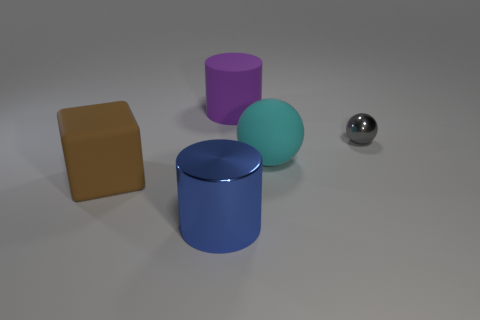What material is the big blue cylinder?
Your response must be concise. Metal. What is the material of the cyan thing that is the same size as the purple matte cylinder?
Provide a succinct answer. Rubber. Are there any brown rubber blocks that have the same size as the purple matte cylinder?
Give a very brief answer. Yes. Are there an equal number of shiny things behind the cyan matte sphere and blue cylinders that are behind the small sphere?
Provide a short and direct response. No. Is the number of brown rubber things greater than the number of objects?
Your answer should be very brief. No. How many shiny things are blue things or yellow spheres?
Offer a very short reply. 1. There is a cylinder in front of the metal thing behind the big rubber thing right of the purple object; what is it made of?
Offer a very short reply. Metal. What color is the thing behind the metal thing right of the big cyan object?
Your answer should be compact. Purple. How many large objects are brown rubber objects or shiny things?
Your answer should be very brief. 2. How many objects have the same material as the big sphere?
Your answer should be very brief. 2. 